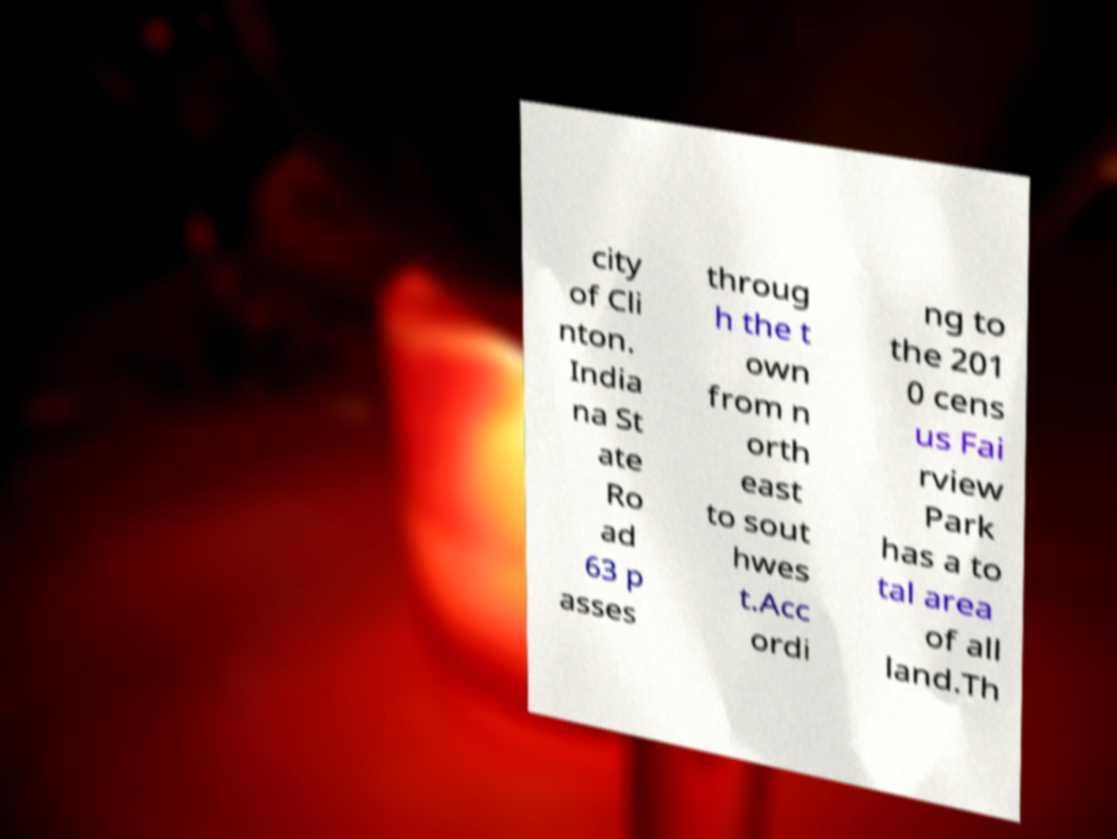There's text embedded in this image that I need extracted. Can you transcribe it verbatim? city of Cli nton. India na St ate Ro ad 63 p asses throug h the t own from n orth east to sout hwes t.Acc ordi ng to the 201 0 cens us Fai rview Park has a to tal area of all land.Th 